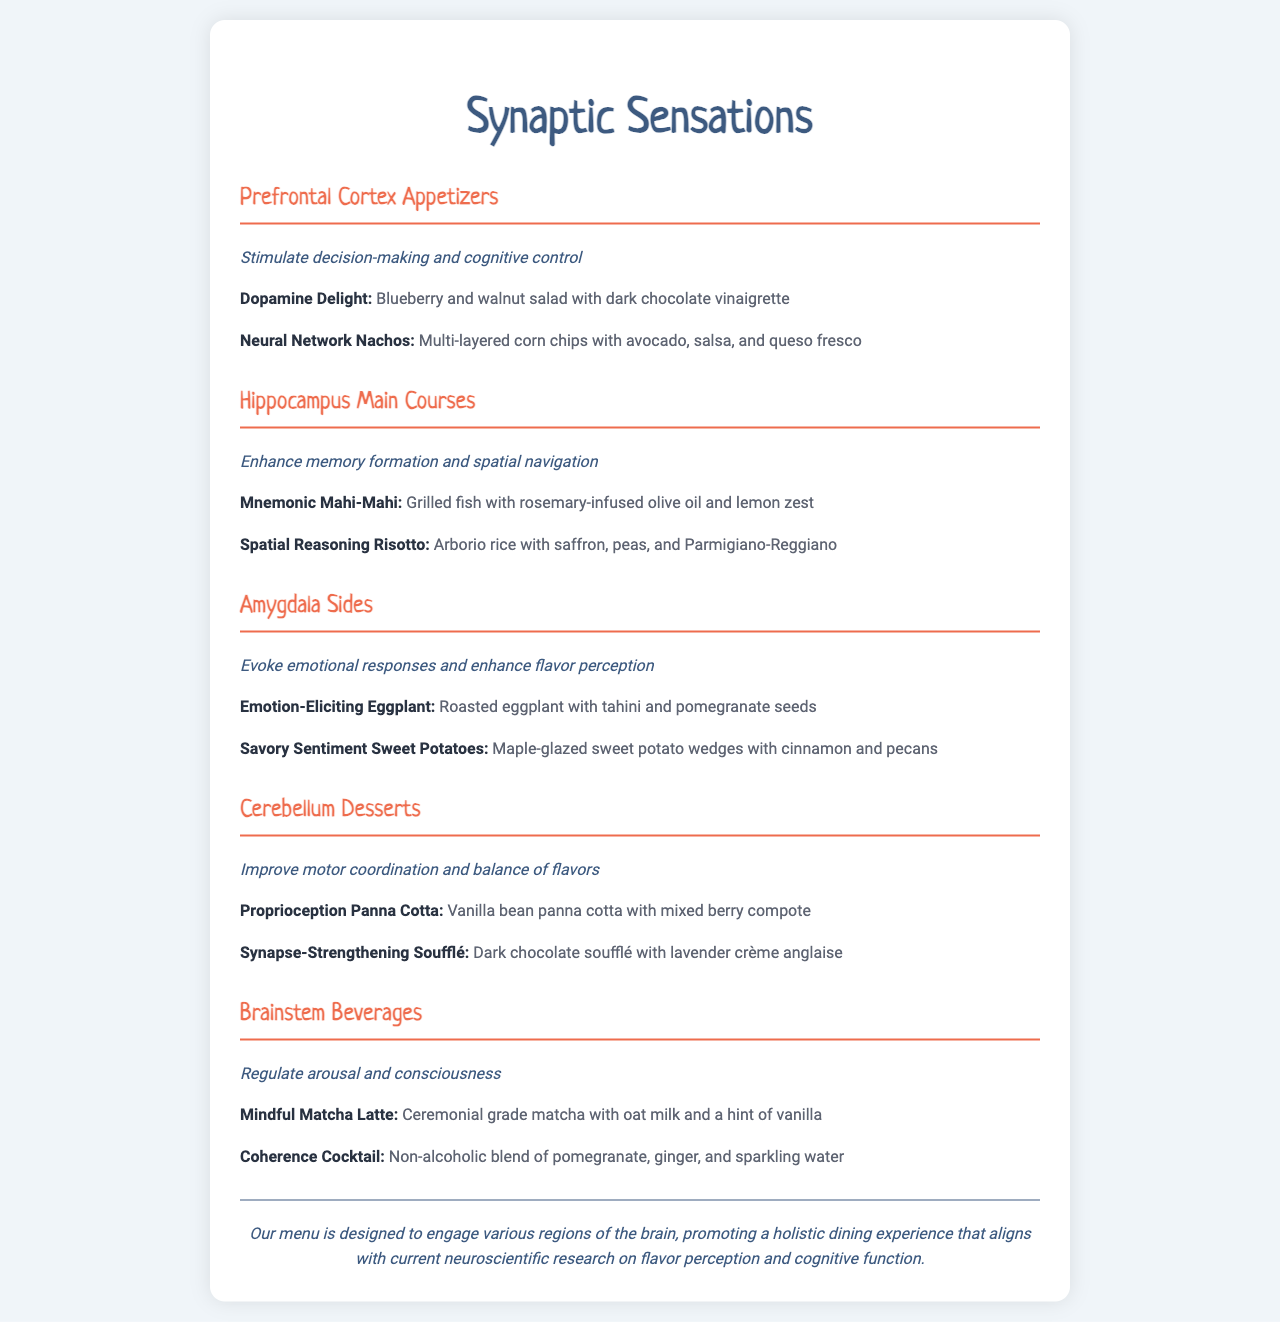What is the name of the first appetizer? The first appetizer listed is "Dopamine Delight," which can be found under the "Prefrontal Cortex Appetizers" section.
Answer: Dopamine Delight Which main course is focused on memory formation? "Mnemonic Mahi-Mahi" is mentioned as enhancing memory formation and is categorized under "Hippocampus Main Courses."
Answer: Mnemonic Mahi-Mahi How many desserts are available on the menu? There are two desserts listed in the "Cerebellum Desserts" section of the menu.
Answer: 2 What type of drink is the "Coherence Cocktail"? The "Coherence Cocktail" is described as a non-alcoholic beverage, found in the "Brainstem Beverages" section.
Answer: Non-alcoholic What ingredient is common in both side dishes? Both side dishes contain sweet potatoes and pomegranate, specifically in "Emotion-Eliciting Eggplant" and "Savory Sentiment Sweet Potatoes."
Answer: Sweet potatoes and pomegranate 